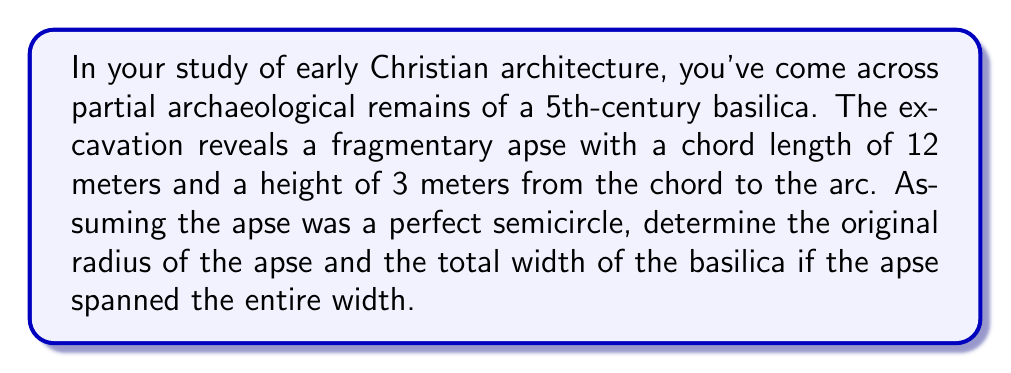What is the answer to this math problem? Let's approach this step-by-step:

1) In a circle, the relationship between the chord length ($c$), height ($h$), and radius ($r$) is given by the equation:

   $$ r = \frac{h}{2} + \frac{c^2}{8h} $$

2) We're given:
   - Chord length ($c$) = 12 meters
   - Height ($h$) = 3 meters

3) Let's substitute these values into our equation:

   $$ r = \frac{3}{2} + \frac{12^2}{8(3)} $$

4) Simplify:
   $$ r = 1.5 + \frac{144}{24} = 1.5 + 6 = 7.5 $$

5) Therefore, the radius of the apse is 7.5 meters.

6) Since the apse is a semicircle that spans the entire width of the basilica, the width of the basilica would be equal to the diameter of the full circle.

7) The diameter is twice the radius:
   $$ \text{width} = 2r = 2(7.5) = 15 \text{ meters} $$

Thus, we've determined that the original apse had a radius of 7.5 meters, and the total width of the basilica was 15 meters.
Answer: Radius: 7.5 m; Width: 15 m 